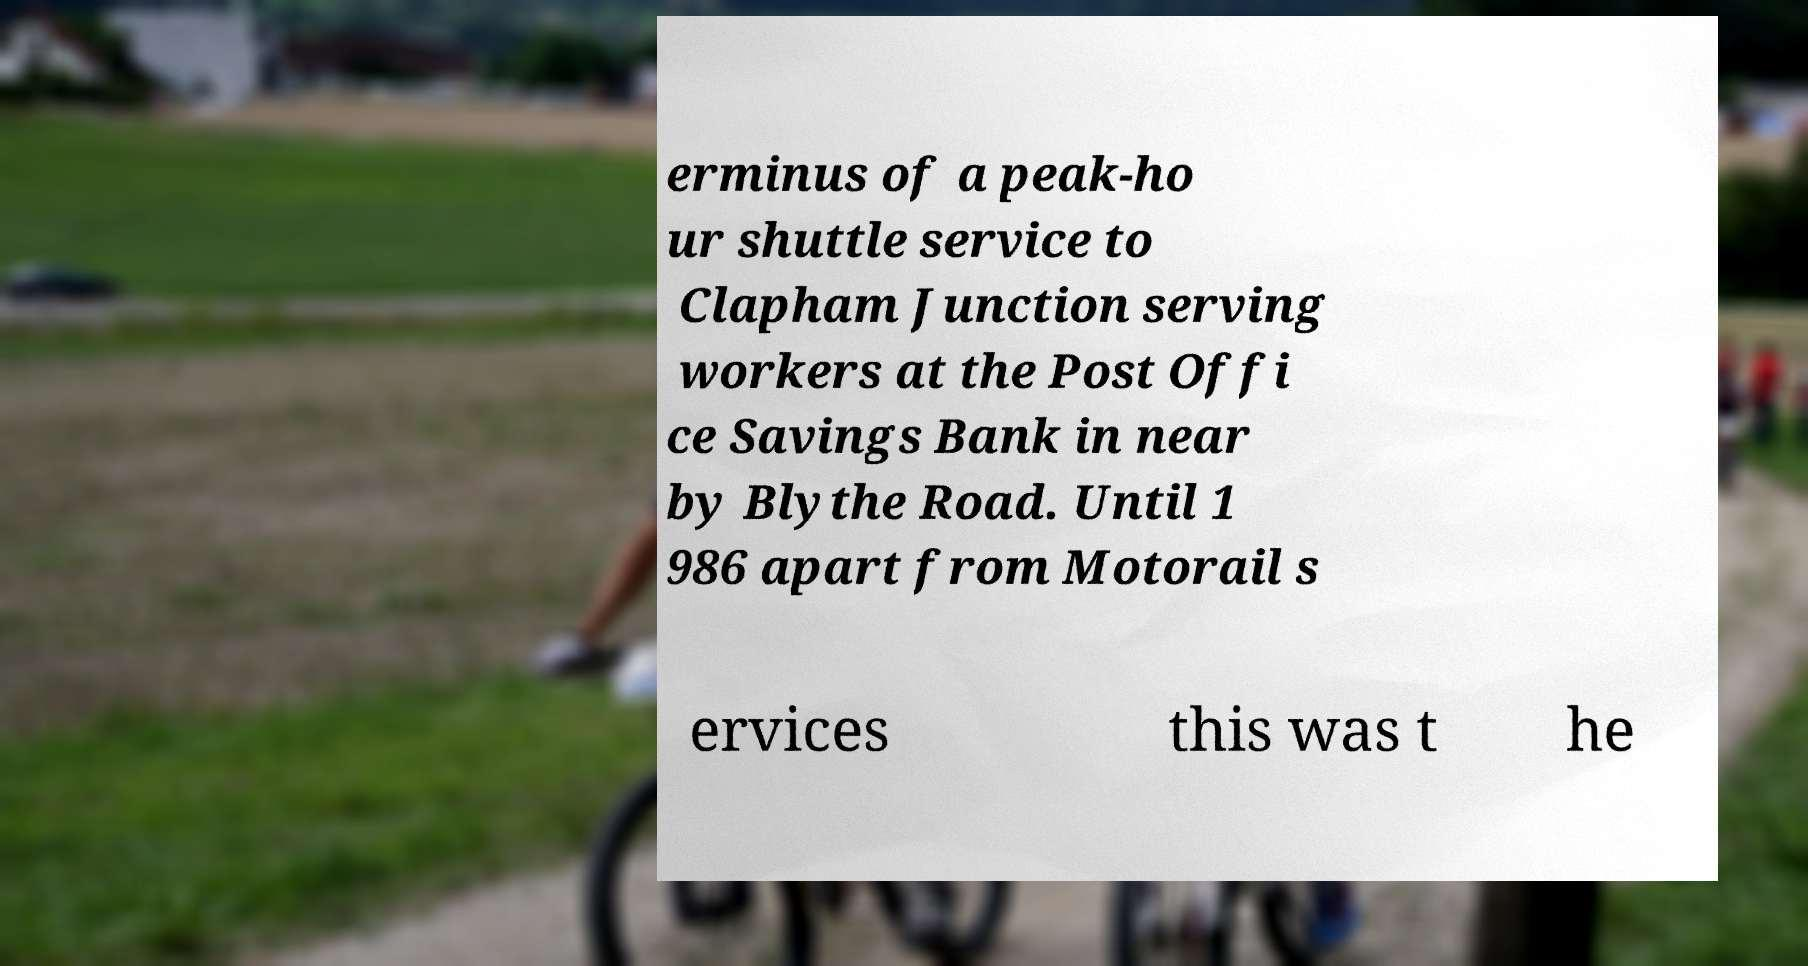Can you accurately transcribe the text from the provided image for me? erminus of a peak-ho ur shuttle service to Clapham Junction serving workers at the Post Offi ce Savings Bank in near by Blythe Road. Until 1 986 apart from Motorail s ervices this was t he 